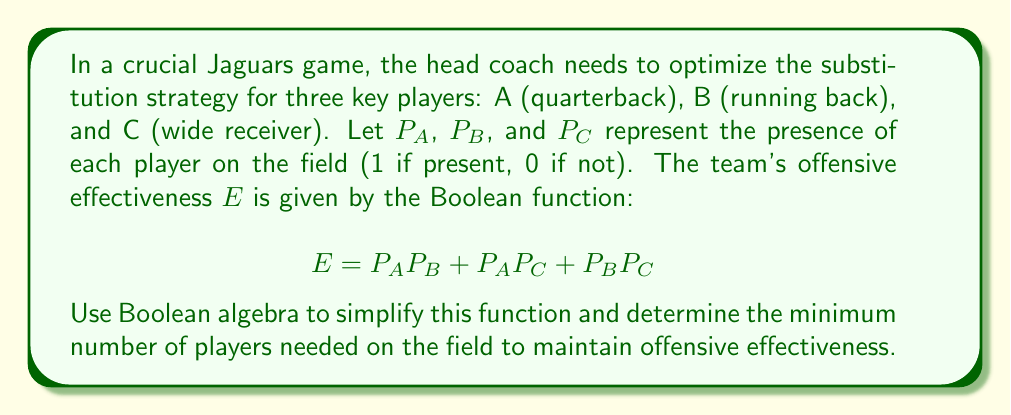Give your solution to this math problem. Let's simplify the Boolean function using the laws of Boolean algebra:

1) Start with the original function:
   $$E = P_A P_B + P_A P_C + P_B P_C$$

2) Factor out $P_A$ from the first two terms:
   $$E = P_A(P_B + P_C) + P_B P_C$$

3) Apply the distributive law:
   $$E = P_A P_B + P_A P_C + P_B P_C$$

   This is the same as our original function, so we can't simplify it further.

4) To determine the minimum number of players needed, we need to find the minimum number of variables that must be 1 for $E$ to be 1.

5) Analyzing the function:
   - If any two variables are 1, $E$ will be 1.
   - If only one variable is 1 or all variables are 0, $E$ will be 0.

6) Therefore, the minimum number of players needed on the field to maintain offensive effectiveness is 2.

This strategy allows the Jaguars to rotate one player out while maintaining offensive effectiveness, providing flexibility in managing player fatigue and matchups.
Answer: 2 players 